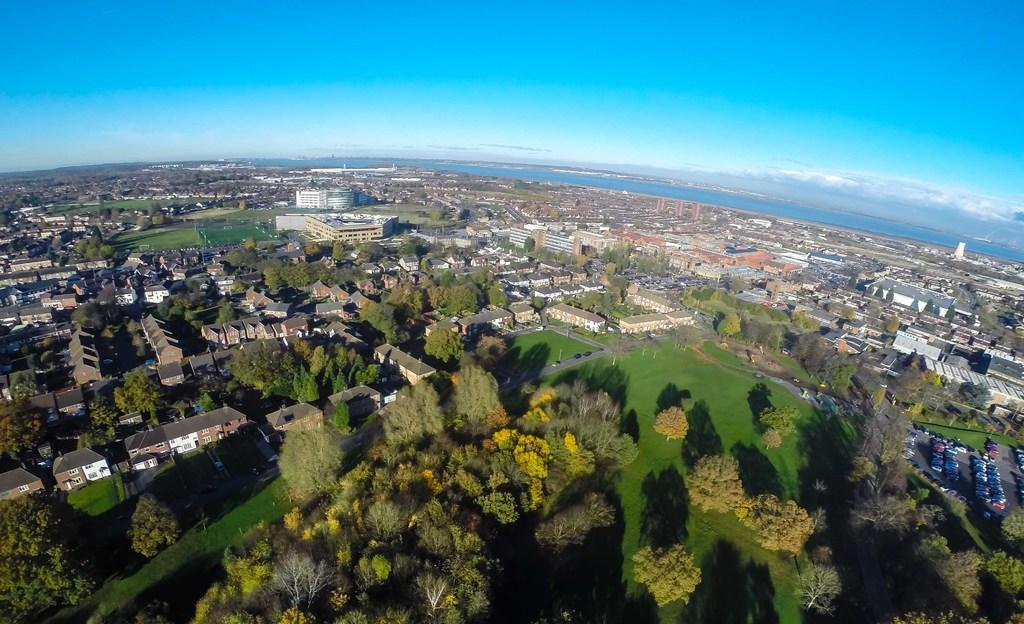What type of vegetation can be seen in the image? There are trees and grass in the image. What type of structures are present in the image? There are houses, buildings, and vehicles in the image. What natural element is visible in the image? Water is visible in the image. What is visible in the background of the image? The sky is visible in the background of the image, with clouds present. What type of birthday celebration is taking place in the image? There is no indication of a birthday celebration in the image. What relation do the people in the image have to each other? There are no people visible in the image, so their relationships cannot be determined. 